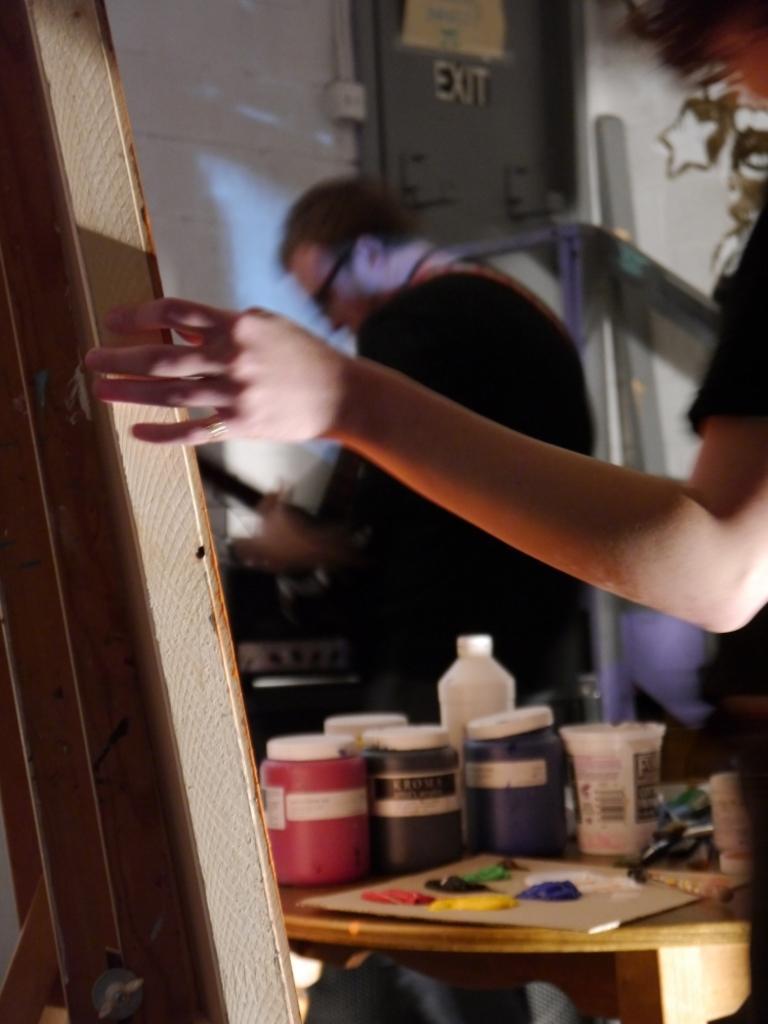Could you give a brief overview of what you see in this image? As we can see in the image there is a white color wall, two people over here and a table. On table there is a board, color, glass, bottle and boxes. 